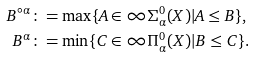Convert formula to latex. <formula><loc_0><loc_0><loc_500><loc_500>B ^ { \circ \alpha } & \colon = \max \{ A \in \infty \Sigma ^ { 0 } _ { \alpha } ( X ) | A \leq B \} , \\ B ^ { \alpha } & \colon = \min \{ C \in \infty \Pi ^ { 0 } _ { \alpha } ( X ) | B \leq C \} .</formula> 